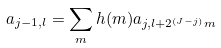Convert formula to latex. <formula><loc_0><loc_0><loc_500><loc_500>a _ { j - 1 , l } = \sum _ { m } h ( m ) a _ { j , l + 2 ^ { ( J - j ) } m }</formula> 